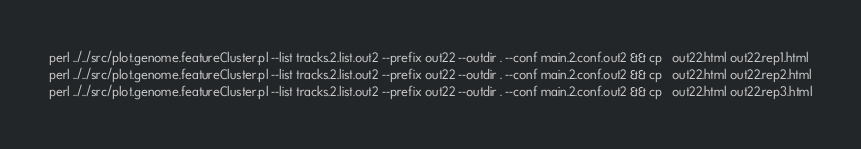<code> <loc_0><loc_0><loc_500><loc_500><_Bash_>perl ../../src/plot.genome.featureCluster.pl --list tracks.2.list.out2 --prefix out22 --outdir . --conf main.2.conf.out2 && cp   out22.html out22.rep1.html
perl ../../src/plot.genome.featureCluster.pl --list tracks.2.list.out2 --prefix out22 --outdir . --conf main.2.conf.out2 && cp   out22.html out22.rep2.html
perl ../../src/plot.genome.featureCluster.pl --list tracks.2.list.out2 --prefix out22 --outdir . --conf main.2.conf.out2 && cp   out22.html out22.rep3.html
</code> 